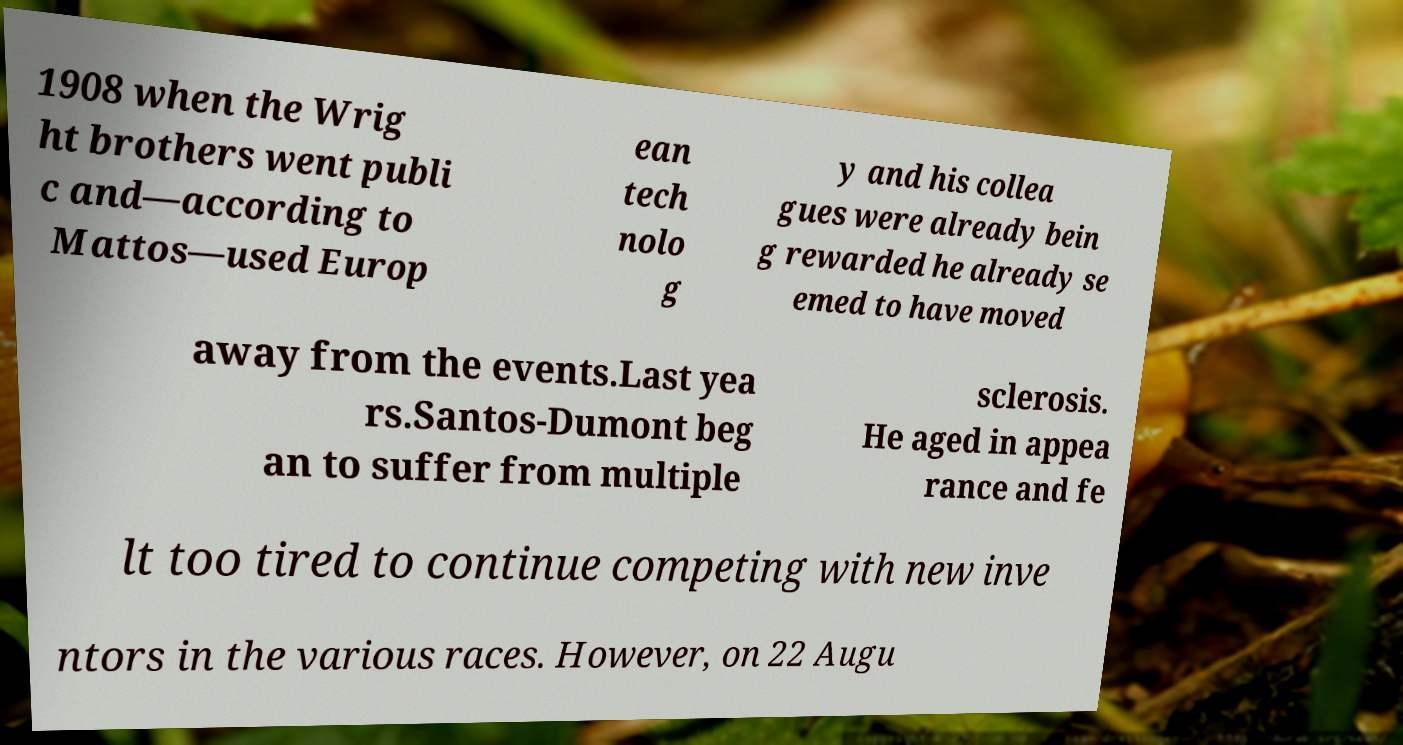There's text embedded in this image that I need extracted. Can you transcribe it verbatim? 1908 when the Wrig ht brothers went publi c and—according to Mattos—used Europ ean tech nolo g y and his collea gues were already bein g rewarded he already se emed to have moved away from the events.Last yea rs.Santos-Dumont beg an to suffer from multiple sclerosis. He aged in appea rance and fe lt too tired to continue competing with new inve ntors in the various races. However, on 22 Augu 